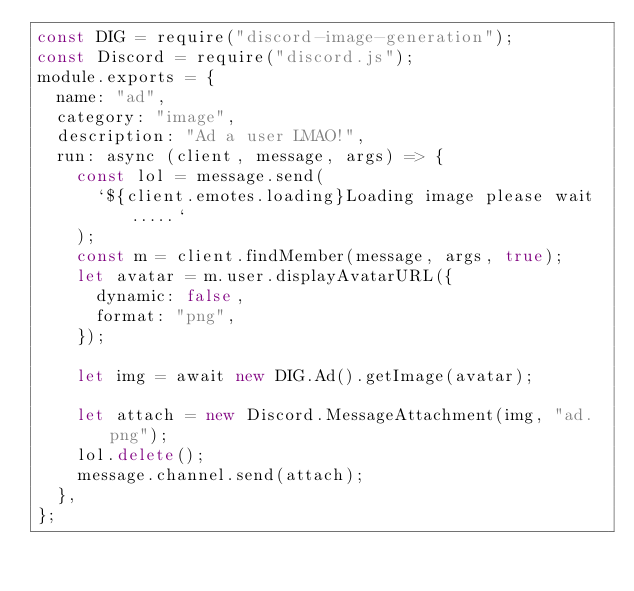<code> <loc_0><loc_0><loc_500><loc_500><_JavaScript_>const DIG = require("discord-image-generation");
const Discord = require("discord.js");
module.exports = {
  name: "ad",
  category: "image",
  description: "Ad a user LMAO!",
  run: async (client, message, args) => {
    const lol = message.send(
      `${client.emotes.loading}Loading image please wait.....`
    );
    const m = client.findMember(message, args, true);
    let avatar = m.user.displayAvatarURL({
      dynamic: false,
      format: "png",
    });

    let img = await new DIG.Ad().getImage(avatar);

    let attach = new Discord.MessageAttachment(img, "ad.png");
    lol.delete();
    message.channel.send(attach);
  },
};
</code> 